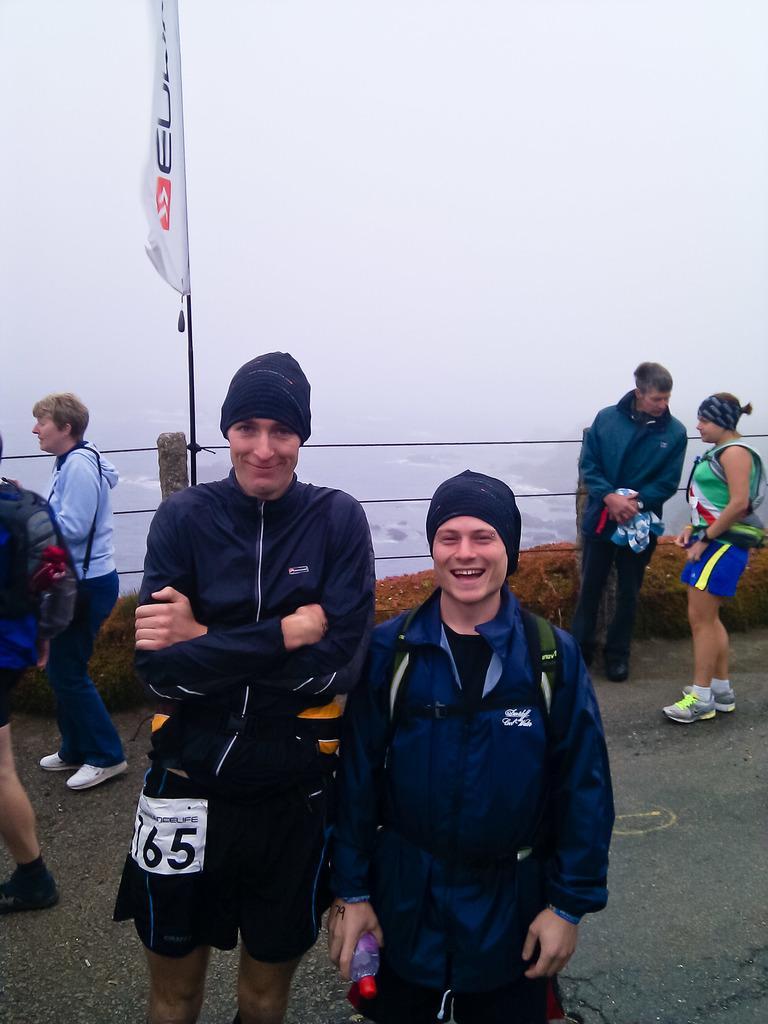Please provide a concise description of this image. In the foreground of the picture there are two person standing wearing blue jacket. On the left there are two people walking. On the right there are two persons standing. In the center of the picture there is a flag and railing, behind the railing there is water. Climate is foggy. 